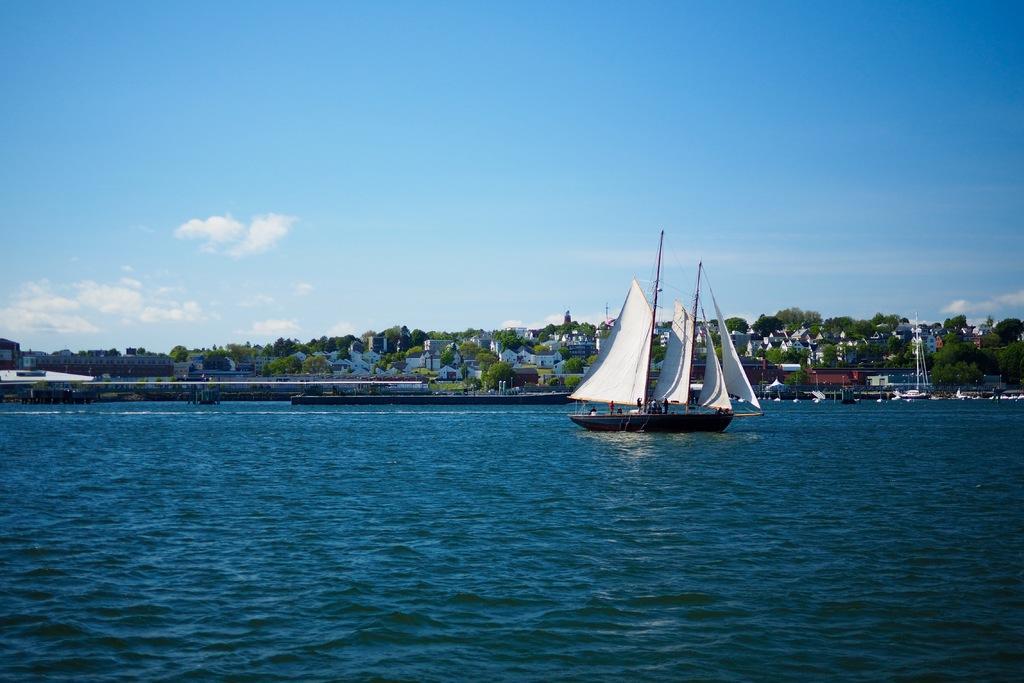In one or two sentences, can you explain what this image depicts? In the image we can see a boat in the water. There are many buildings and trees. Here we can see water and pale blue sky. 